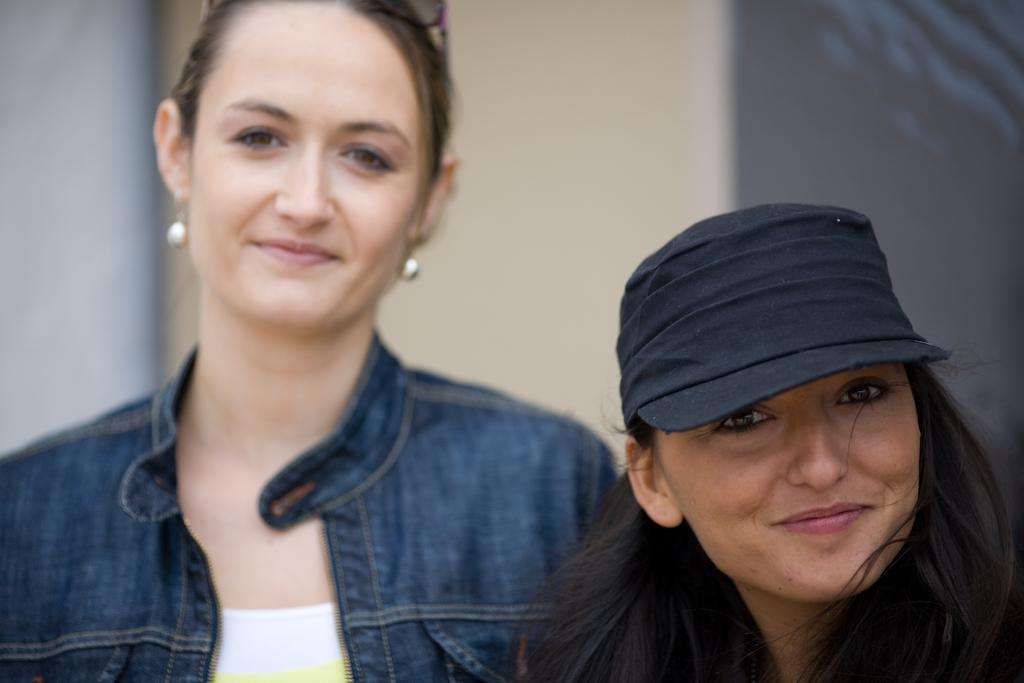How many people are in the image? There are two ladies in the image. What is one of the ladies wearing on her head? One of the ladies is wearing a cap. Can you describe the background of the image? The background of the image is blurred. What type of cheese is the lady holding in the image? There is no cheese present in the image; both ladies are empty-handed. 